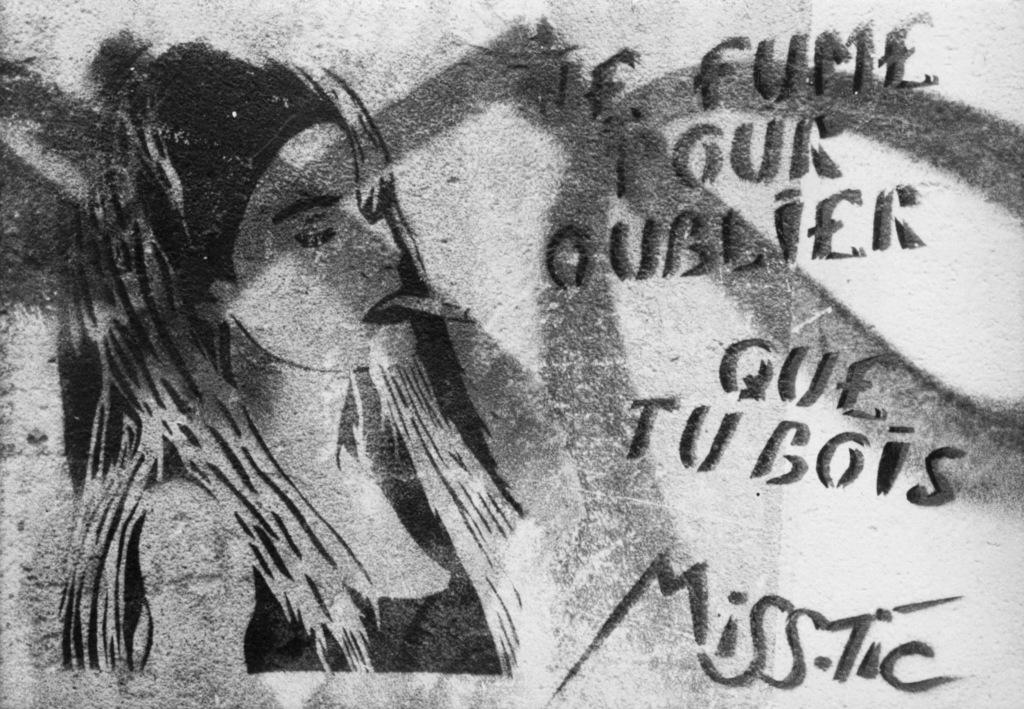What is depicted in the image? There is a drawing of a woman in the image. Are there any additional elements in the image besides the drawing? Yes, there are words on the wall in the image. What type of feast is being prepared in the image? There is no feast or any indication of food preparation in the image; it only contains a drawing of a woman and words on the wall. How many snakes can be seen slithering on the floor in the image? There are no snakes present in the image. 